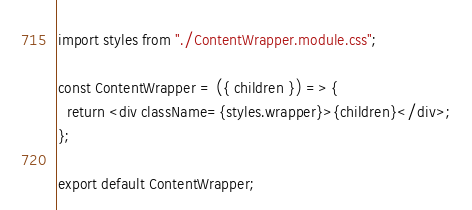<code> <loc_0><loc_0><loc_500><loc_500><_JavaScript_>import styles from "./ContentWrapper.module.css";

const ContentWrapper = ({ children }) => {
  return <div className={styles.wrapper}>{children}</div>;
};

export default ContentWrapper;
</code> 